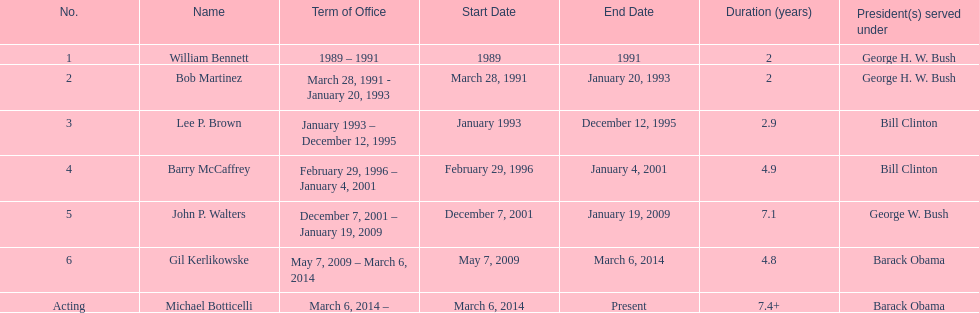What was the duration of the first director's term in office? 2 years. 